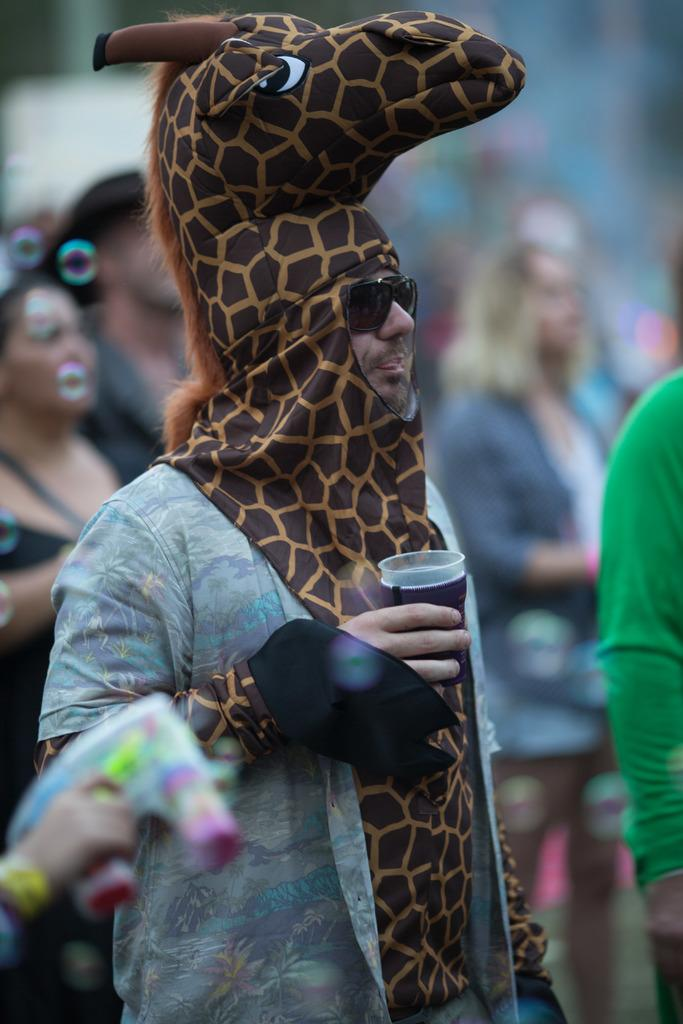What is the main subject of the image? The main subject of the image is a man. What is the man wearing? The man is wearing a dress with a giraffe pattern. What is the man holding in his hand? The man is holding a glass in his hand. What is the man's facial expression or focus in the image? The man is staring at something. Are there any other people in the image? Yes, there are other people standing behind the man. What historical event is being commemorated in the image? There is no indication of a historical event being commemorated in the image. 